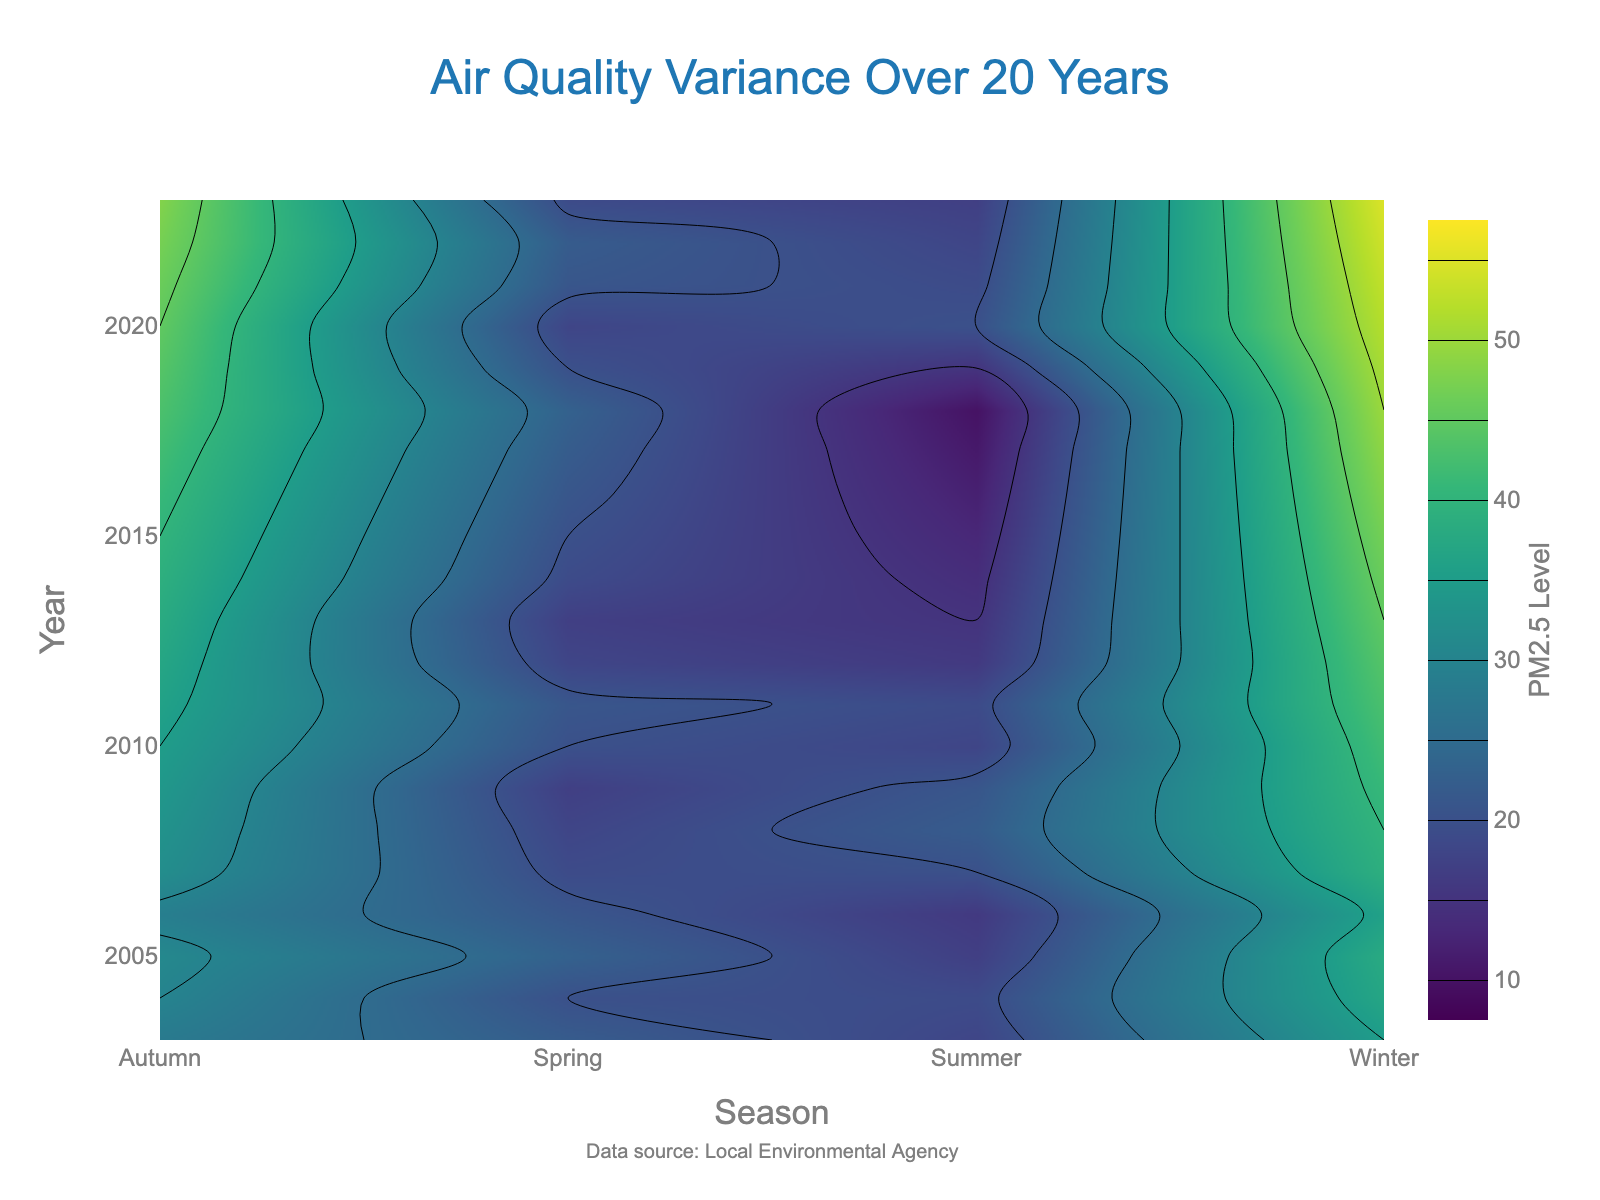What is the title of the contour plot? The title is located at the top center of the plot and it clearly describes what the visual represents.
Answer: Air Quality Variance Over 20 Years What does the colorbar title indicate? The title of the colorbar, usually situated alongside the color scale, indicates what the colors represent numerically.
Answer: PM2.5 Level In which season and year was the air quality the worst (highest PM2.5 level)? By looking at the darkest area on the contour plot, which corresponds to the highest value on the color scale, we can find the season and year with the highest PM2.5 level.
Answer: Winter 2023 How has the air quality during summer changed from 2003 to 2023? Observing the color gradient along the 'Summer' column from 2003 to 2023 shows how the color shifts, indicating changes in PM2.5 levels over the years.
Answer: It has improved (PM2.5 levels decreased) Which year had the least air quality variance across all seasons? To find this, look for a year where the contour lines are closest together, indicating minimal variance in PM2.5 levels across seasons.
Answer: 2005 What is the average PM2.5 level in the year 2013 across all seasons? Sum the PM2.5 levels for all seasons in 2013 (Winter, Spring, Summer, Autumn) and divide by 4.
Answer: (45 + 17 + 15 + 38) / 4 = 28.75 Compare the air quality in Spring for the years 2010 and 2020. Which year had better air quality? Look at the PM2.5 levels for Spring in both years and compare their values.
Answer: 2020 had better air quality How does the air quality in autumn of 2022 compare to that in autumn of 2003? Compare the PM2.5 levels for Autumn in both years. This involves subtracting the 2003 value from the 2022 value to see the change.
Answer: It got worse (47 - 28 = 19 increase) What pattern can be observed about the air quality in winter over the years? Look for a trend by observing the color changes for Winter from 2003 to 2023.
Answer: It consistently worsened (increased PM2.5 levels) Identify the season with the most consistent air quality improvement over the years. Observe the columns across the plot, looking for the season with a clear and consistent color change indicating improved air quality (lighter shade over time).
Answer: Summer 